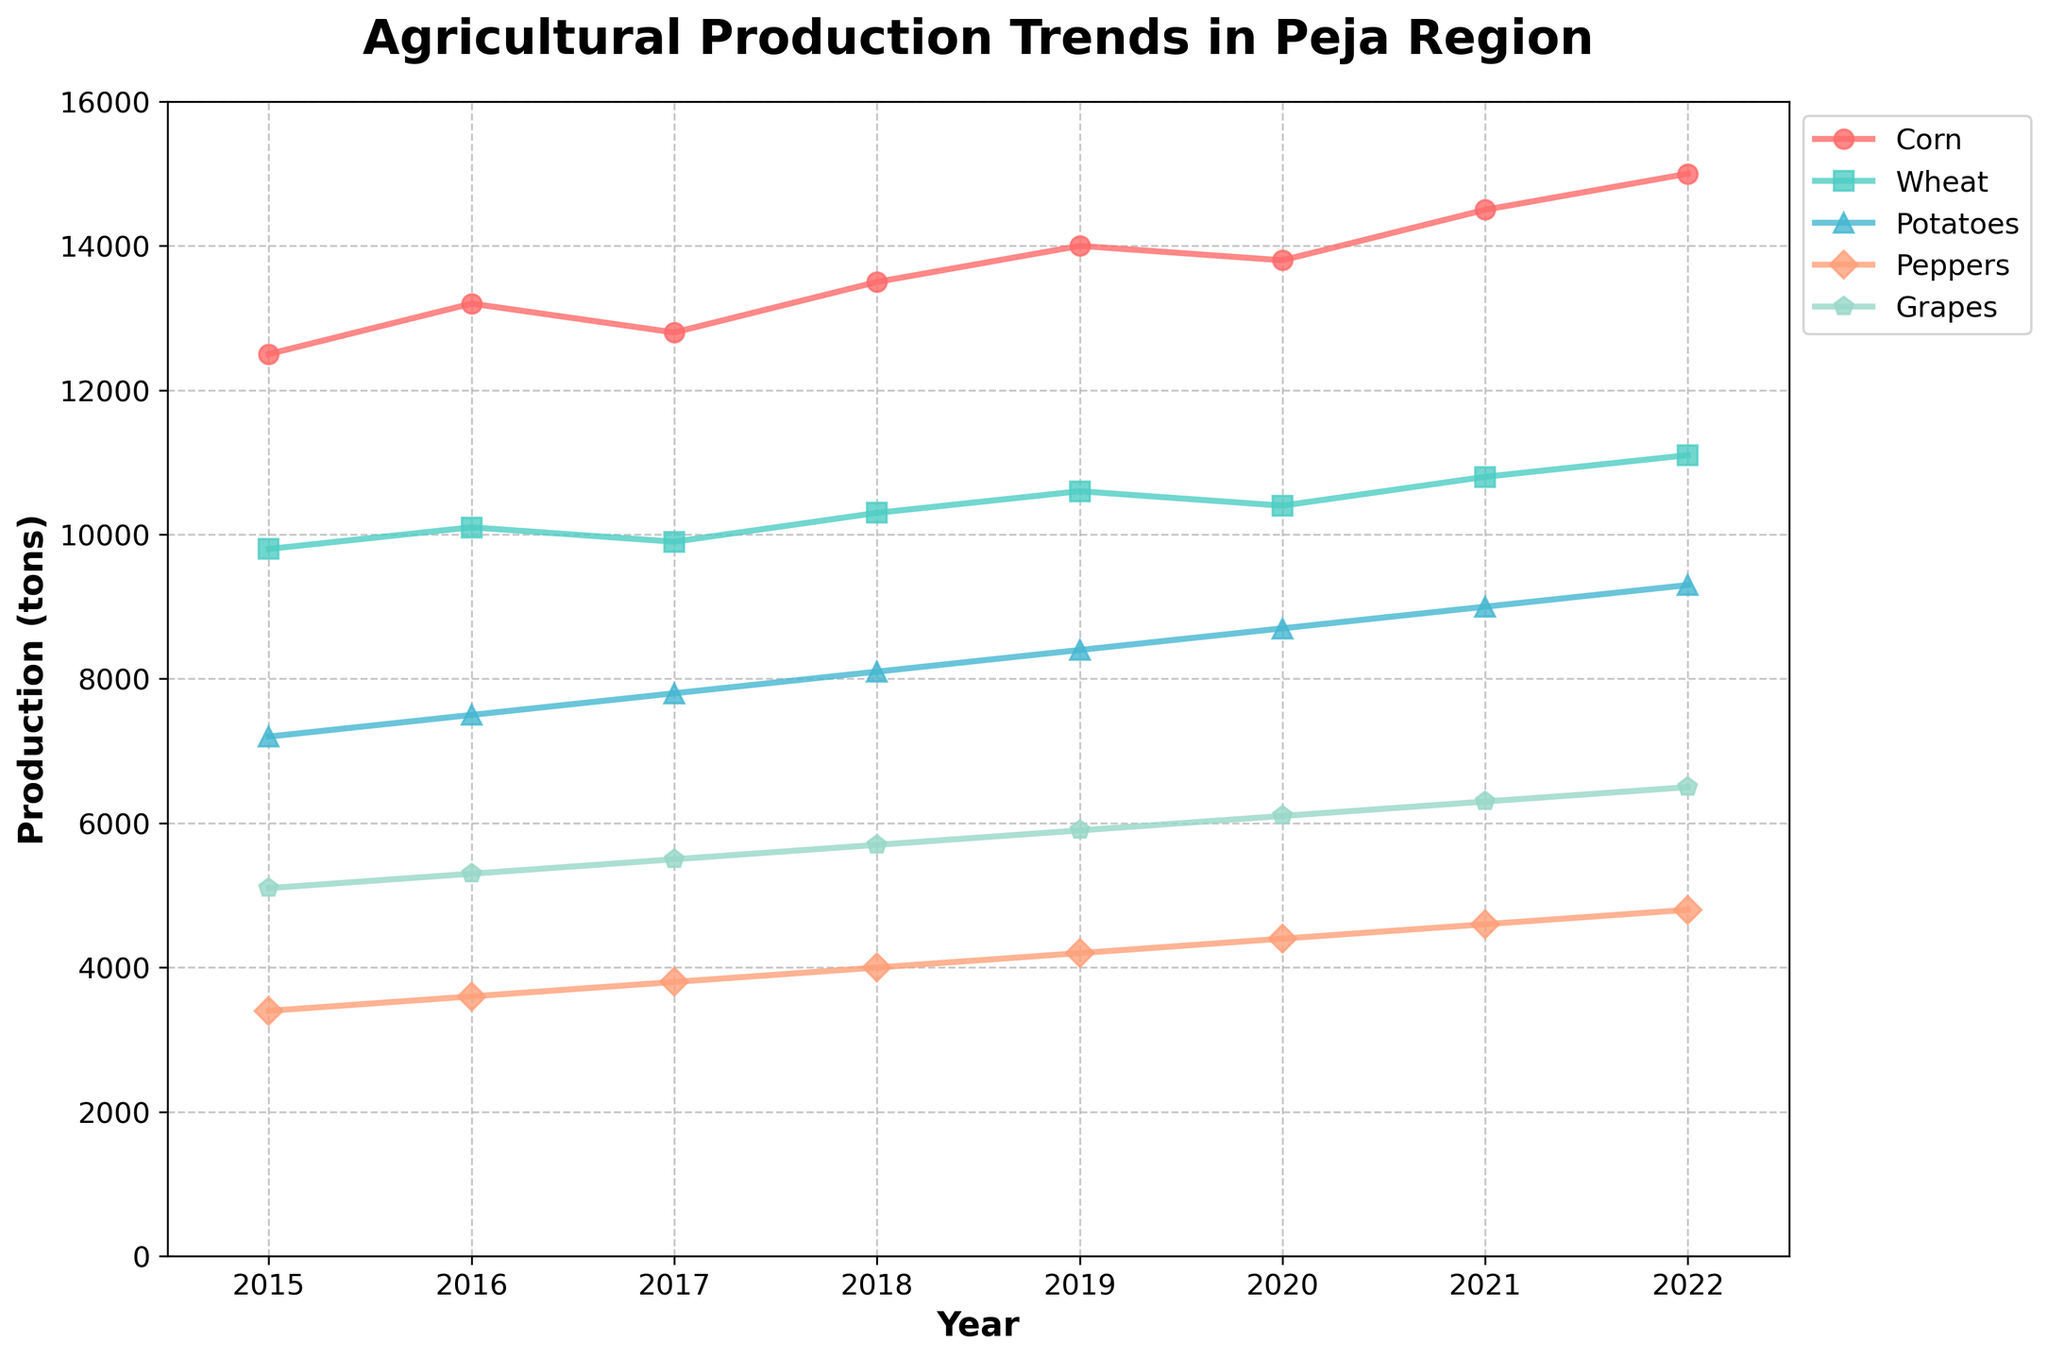What crop has the highest production in 2022? In the year 2022, each crop's production is shown by the height of their respective lines. Grapes have the highest production with a visible peak.
Answer: Grapes Which crop had the least increase in production from 2015 to 2022? To identify the least increase, compare the production values in 2015 and 2022 for all crops. Corn increases from 12500 to 15000, Wheat from 9800 to 11100, Potatoes from 7200 to 9300, Peppers from 3400 to 4800, and Grapes from 5100 to 6500. Peppers have the smallest increment of 1400 tons.
Answer: Peppers How did the production of Corn and Wheat compare in 2017? Look at the production levels of Corn and Wheat for the year 2017. Corn's production is 12800 tons and Wheat's production is 9900 tons, so Corn has a higher production than Wheat in 2017.
Answer: Corn has higher production than Wheat What is the average production of Potatoes over the years 2015 to 2022? Sum the production values of Potatoes for all given years and divide by the number of years: (7200 + 7500 + 7800 + 8100 + 8400 + 8700 + 9000 + 9300) / 8 = 8125 tons.
Answer: 8125 tons Which year saw the highest production increase in Grapes compared to the previous year? Calculate the year-over-year difference in Grapes' production for each year: (2016-2015)=200, (2017-2016)=200, (2018-2017)=200, (2019-2018)=200, (2020-2019)=200, (2021-2020)=200, (2022-2021)=200. Each increasing equally, pick any.
Answer: 2016 to 2017 By how much did Pepper production increase from 2015 to 2022? Subtract the Pepper production value from 2015 from its value in 2022: 4800 - 3400 = 1400 tons.
Answer: 1400 tons Which crop showed a consistent increase in production every year? Check each crop's production numbers year by year. All crops except Corn and Grapes show continuous annual increments from 2015 to 2022.
Answer: Wheat and Potatoes 